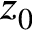<formula> <loc_0><loc_0><loc_500><loc_500>z _ { 0 }</formula> 